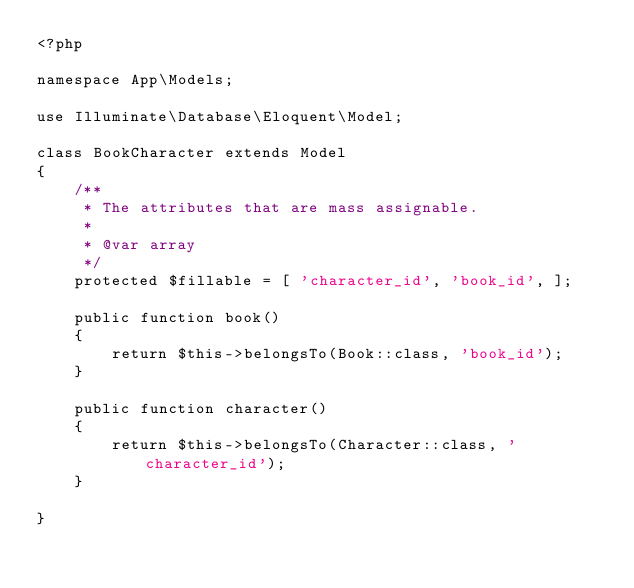<code> <loc_0><loc_0><loc_500><loc_500><_PHP_><?php

namespace App\Models;

use Illuminate\Database\Eloquent\Model;

class BookCharacter extends Model
{
    /**
     * The attributes that are mass assignable.
     *
     * @var array
     */
    protected $fillable = [ 'character_id', 'book_id', ];

    public function book()
    {
        return $this->belongsTo(Book::class, 'book_id');
    }

    public function character() 
    {
        return $this->belongsTo(Character::class, 'character_id');
    }

}
</code> 